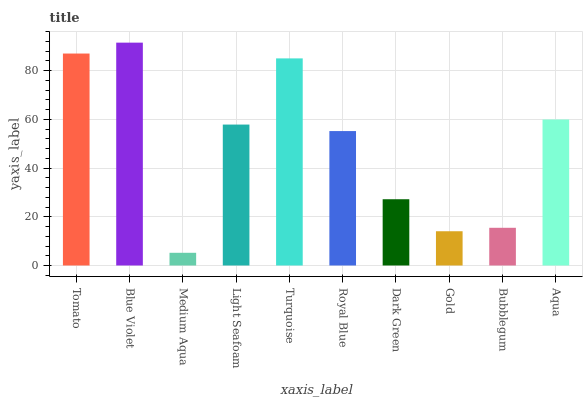Is Medium Aqua the minimum?
Answer yes or no. Yes. Is Blue Violet the maximum?
Answer yes or no. Yes. Is Blue Violet the minimum?
Answer yes or no. No. Is Medium Aqua the maximum?
Answer yes or no. No. Is Blue Violet greater than Medium Aqua?
Answer yes or no. Yes. Is Medium Aqua less than Blue Violet?
Answer yes or no. Yes. Is Medium Aqua greater than Blue Violet?
Answer yes or no. No. Is Blue Violet less than Medium Aqua?
Answer yes or no. No. Is Light Seafoam the high median?
Answer yes or no. Yes. Is Royal Blue the low median?
Answer yes or no. Yes. Is Gold the high median?
Answer yes or no. No. Is Medium Aqua the low median?
Answer yes or no. No. 